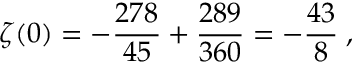<formula> <loc_0><loc_0><loc_500><loc_500>\zeta ( 0 ) = - { \frac { 2 7 8 } { 4 5 } } + { \frac { 2 8 9 } { 3 6 0 } } = - { \frac { 4 3 } { 8 } } \, ,</formula> 